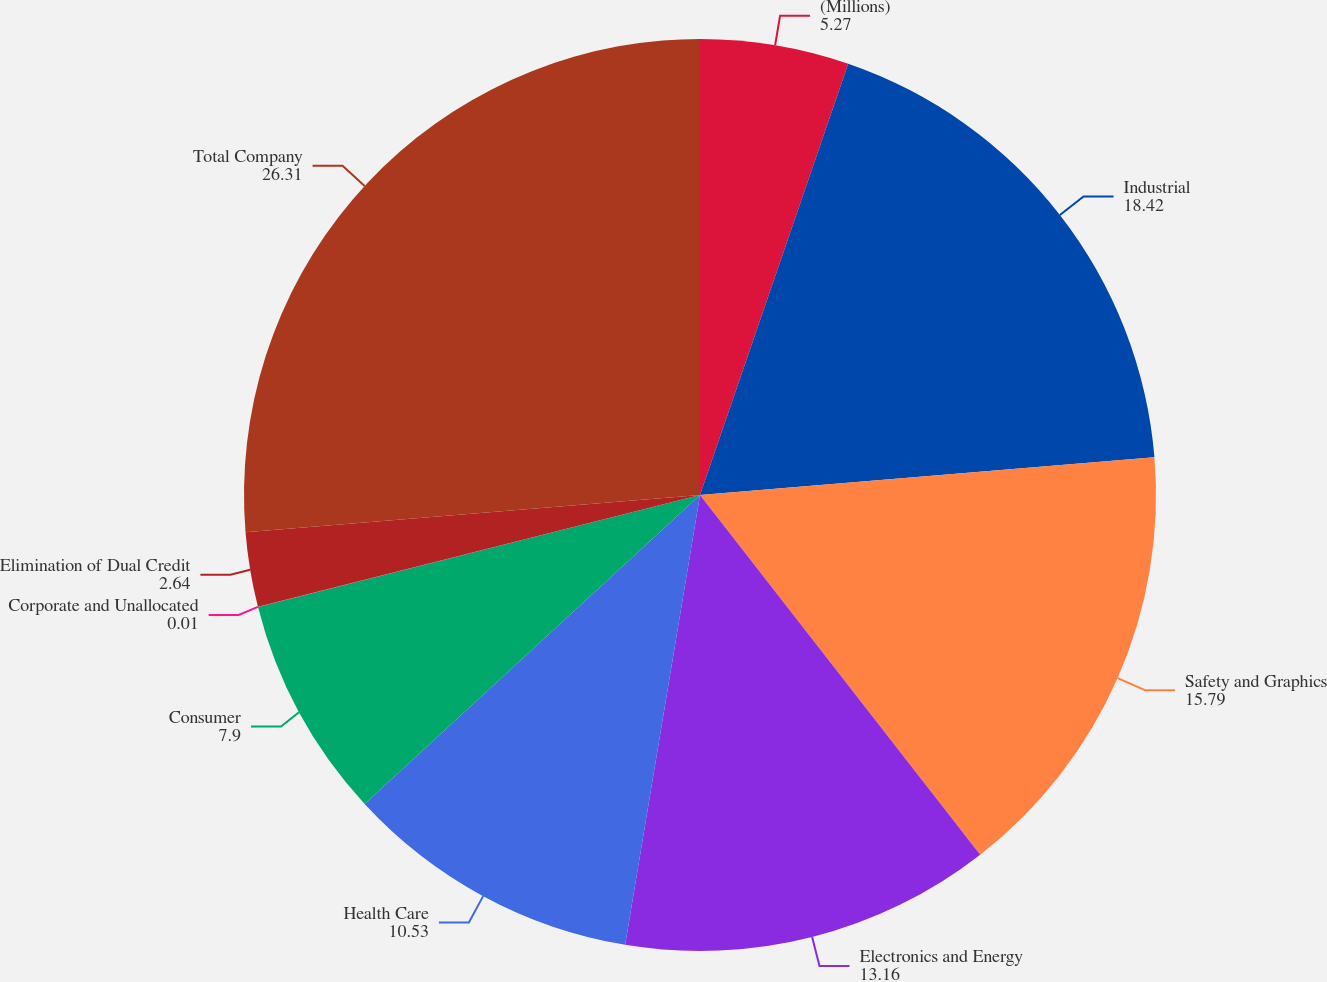Convert chart. <chart><loc_0><loc_0><loc_500><loc_500><pie_chart><fcel>(Millions)<fcel>Industrial<fcel>Safety and Graphics<fcel>Electronics and Energy<fcel>Health Care<fcel>Consumer<fcel>Corporate and Unallocated<fcel>Elimination of Dual Credit<fcel>Total Company<nl><fcel>5.27%<fcel>18.42%<fcel>15.79%<fcel>13.16%<fcel>10.53%<fcel>7.9%<fcel>0.01%<fcel>2.64%<fcel>26.31%<nl></chart> 